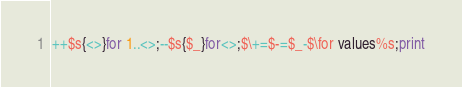Convert code to text. <code><loc_0><loc_0><loc_500><loc_500><_Perl_>++$s{<>}for 1..<>;--$s{$_}for<>;$\+=$-=$_-$\for values%s;print</code> 